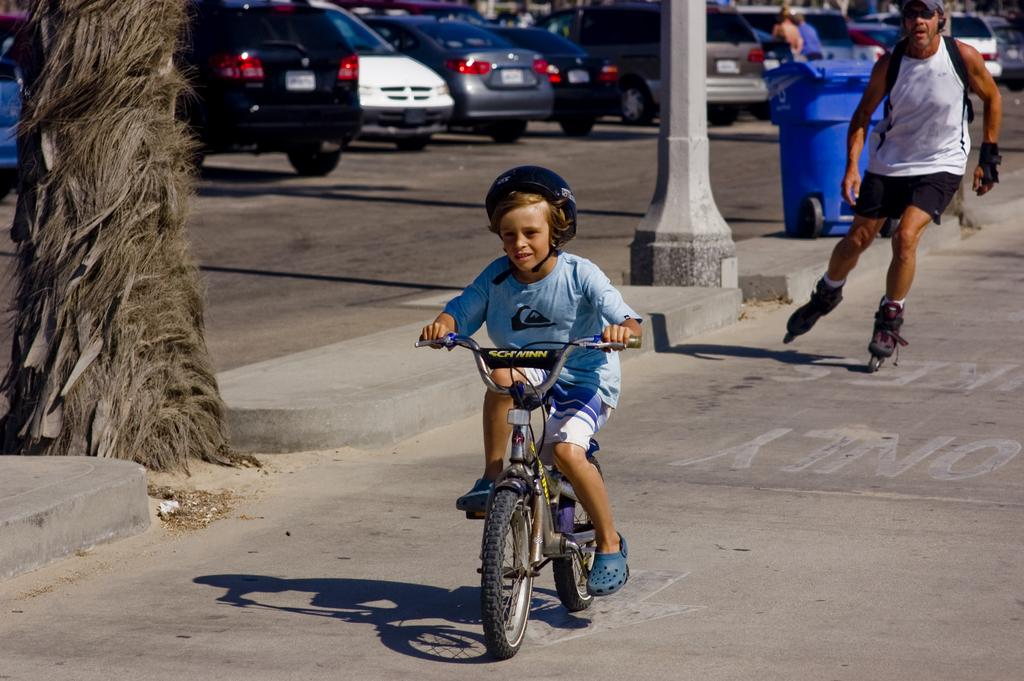What is the main subject of the image? The main subject of the image is a kid. What is the kid doing in the image? The kid is riding a bicycle. What can be seen in the background of the image? There are vehicles, a person skating, and a dust bin in the background of the image. What type of cloud can be seen in the image? There is no cloud present in the image. What discovery was made by the kid while riding the bicycle? The image does not show any discovery made by the kid; it only shows the kid riding a bicycle. 